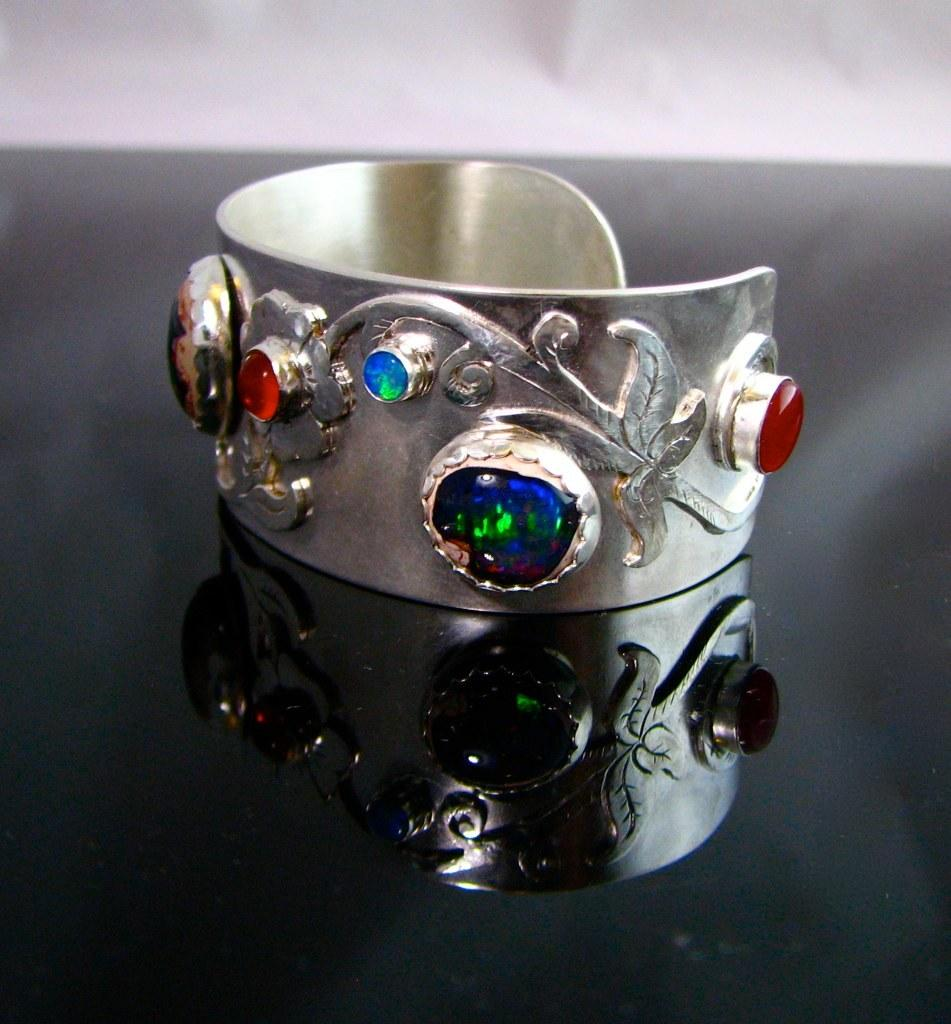What is the main subject of the image? The main subject of the image is a ring with designs and stones. What is the ring placed on in the image? The ring is on a black surface. Can you describe any additional details about the ring's appearance in the image? There is a reflection of the ring on the black surface. What type of territory is being claimed by the beetle in the image? There is no beetle present in the image, so no territory is being claimed. 